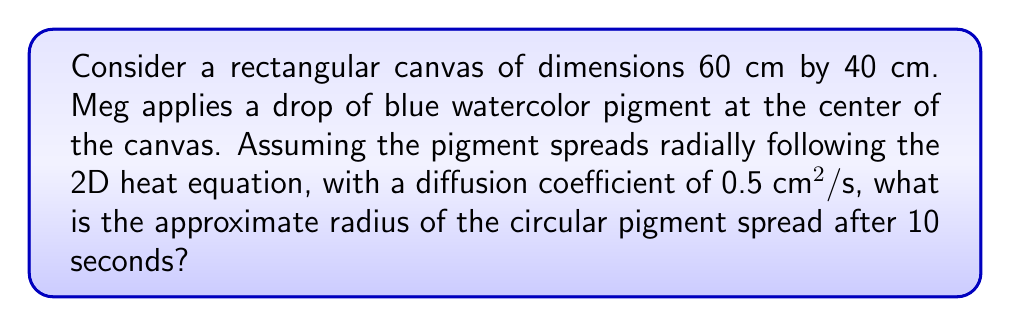Provide a solution to this math problem. To solve this problem, we'll use the fundamental solution of the 2D heat equation, which describes the radial spread of a point source:

1) The fundamental solution in 2D is given by:
   $$u(r,t) = \frac{1}{4\pi Dt} e^{-\frac{r^2}{4Dt}}$$
   where $u$ is the concentration, $r$ is the radial distance, $t$ is time, and $D$ is the diffusion coefficient.

2) We're interested in finding $r$ when $t = 10$ s and $D = 0.5$ cm²/s.

3) The spread of pigment can be approximated by considering where the concentration falls to a small fraction of its peak value. A common choice is $e^{-1} \approx 0.368$ of the maximum.

4) Setting $u(r,t) = e^{-1} u(0,t)$, we get:
   $$e^{-1} \cdot \frac{1}{4\pi Dt} = \frac{1}{4\pi Dt} e^{-\frac{r^2}{4Dt}}$$

5) Simplifying:
   $$e^{-1} = e^{-\frac{r^2}{4Dt}}$$

6) Taking the natural log of both sides:
   $$-1 = -\frac{r^2}{4Dt}$$

7) Solving for $r$:
   $$r = \sqrt{4Dt}$$

8) Substituting the values:
   $$r = \sqrt{4 \cdot 0.5 \cdot 10} = \sqrt{20} \approx 4.47 \text{ cm}$$

Therefore, after 10 seconds, the pigment will have spread to a radius of approximately 4.47 cm.
Answer: 4.47 cm 